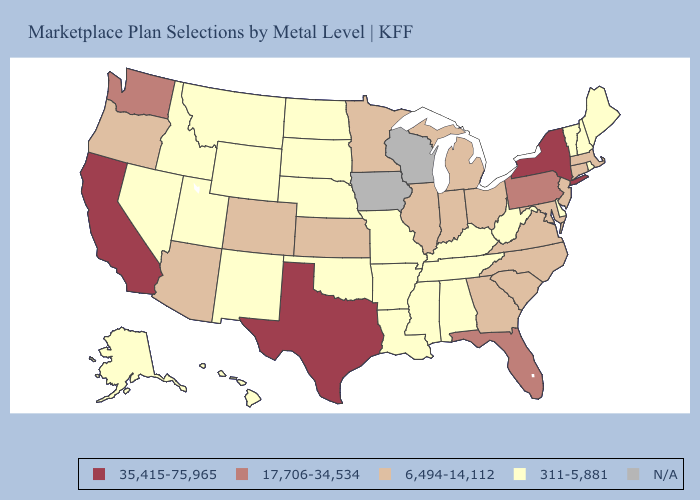Does California have the lowest value in the USA?
Be succinct. No. What is the highest value in the USA?
Keep it brief. 35,415-75,965. Does Washington have the lowest value in the USA?
Keep it brief. No. What is the value of Maryland?
Short answer required. 6,494-14,112. Does the first symbol in the legend represent the smallest category?
Keep it brief. No. Does California have the highest value in the USA?
Concise answer only. Yes. Does Washington have the lowest value in the USA?
Answer briefly. No. What is the value of Montana?
Answer briefly. 311-5,881. What is the value of Washington?
Write a very short answer. 17,706-34,534. What is the lowest value in the USA?
Keep it brief. 311-5,881. How many symbols are there in the legend?
Keep it brief. 5. What is the lowest value in the MidWest?
Quick response, please. 311-5,881. What is the value of Ohio?
Write a very short answer. 6,494-14,112. 